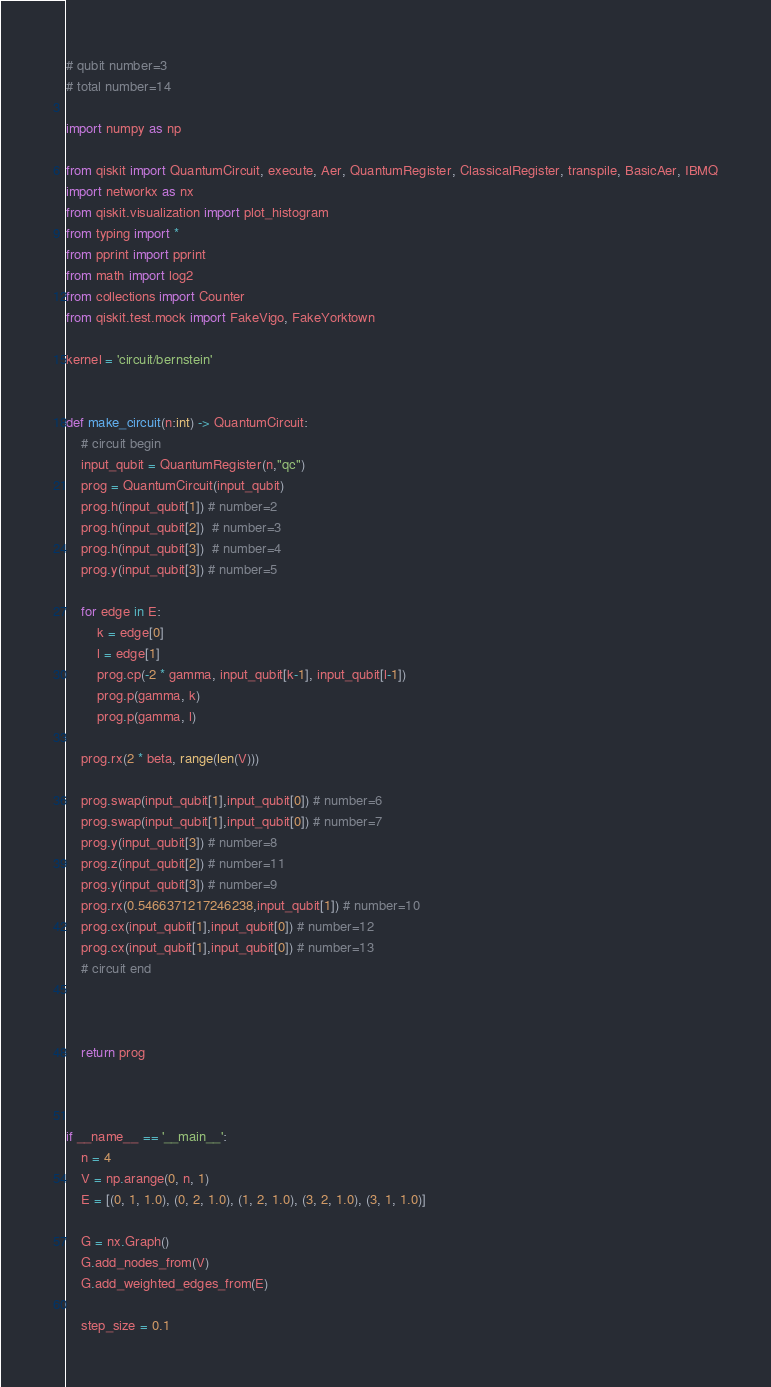<code> <loc_0><loc_0><loc_500><loc_500><_Python_># qubit number=3
# total number=14

import numpy as np

from qiskit import QuantumCircuit, execute, Aer, QuantumRegister, ClassicalRegister, transpile, BasicAer, IBMQ
import networkx as nx
from qiskit.visualization import plot_histogram
from typing import *
from pprint import pprint
from math import log2
from collections import Counter
from qiskit.test.mock import FakeVigo, FakeYorktown

kernel = 'circuit/bernstein'


def make_circuit(n:int) -> QuantumCircuit:
    # circuit begin
    input_qubit = QuantumRegister(n,"qc")
    prog = QuantumCircuit(input_qubit)
    prog.h(input_qubit[1]) # number=2
    prog.h(input_qubit[2])  # number=3
    prog.h(input_qubit[3])  # number=4
    prog.y(input_qubit[3]) # number=5

    for edge in E:
        k = edge[0]
        l = edge[1]
        prog.cp(-2 * gamma, input_qubit[k-1], input_qubit[l-1])
        prog.p(gamma, k)
        prog.p(gamma, l)

    prog.rx(2 * beta, range(len(V)))

    prog.swap(input_qubit[1],input_qubit[0]) # number=6
    prog.swap(input_qubit[1],input_qubit[0]) # number=7
    prog.y(input_qubit[3]) # number=8
    prog.z(input_qubit[2]) # number=11
    prog.y(input_qubit[3]) # number=9
    prog.rx(0.5466371217246238,input_qubit[1]) # number=10
    prog.cx(input_qubit[1],input_qubit[0]) # number=12
    prog.cx(input_qubit[1],input_qubit[0]) # number=13
    # circuit end



    return prog



if __name__ == '__main__':
    n = 4
    V = np.arange(0, n, 1)
    E = [(0, 1, 1.0), (0, 2, 1.0), (1, 2, 1.0), (3, 2, 1.0), (3, 1, 1.0)]

    G = nx.Graph()
    G.add_nodes_from(V)
    G.add_weighted_edges_from(E)

    step_size = 0.1
</code> 